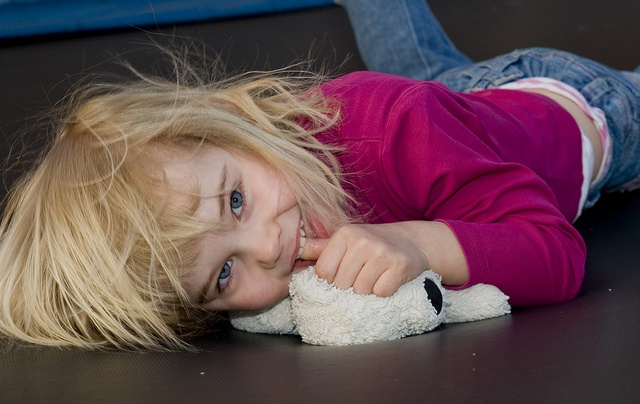Describe the objects in this image and their specific colors. I can see people in blue, tan, gray, and purple tones and teddy bear in blue, darkgray, lightgray, and gray tones in this image. 